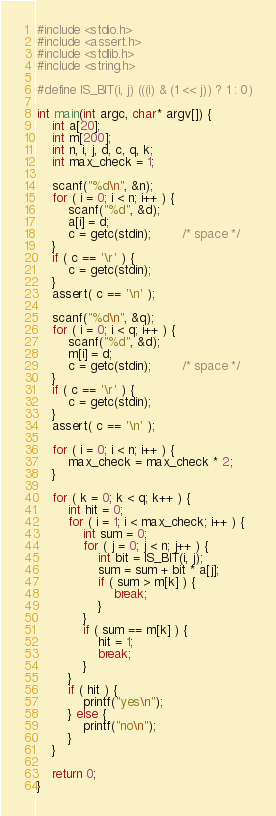<code> <loc_0><loc_0><loc_500><loc_500><_C_>#include <stdio.h>
#include <assert.h>
#include <stdlib.h>
#include <string.h>

#define IS_BIT(i, j) (((i) & (1 << j)) ? 1 : 0)

int main(int argc, char* argv[]) {
    int a[20];
    int m[200];
    int n, i, j, d, c, q, k;
    int max_check = 1;

    scanf("%d\n", &n);
    for ( i = 0; i < n; i++ ) {
        scanf("%d", &d);
        a[i] = d;
        c = getc(stdin);        /* space */
    }
    if ( c == '\r' ) {
        c = getc(stdin);
    }
    assert( c == '\n' );

    scanf("%d\n", &q);
    for ( i = 0; i < q; i++ ) {
        scanf("%d", &d);
        m[i] = d;
        c = getc(stdin);        /* space */
    }
    if ( c == '\r' ) {
        c = getc(stdin);
    }
    assert( c == '\n' );

    for ( i = 0; i < n; i++ ) {
        max_check = max_check * 2;
    }

    for ( k = 0; k < q; k++ ) {
        int hit = 0;
        for ( i = 1; i < max_check; i++ ) {
            int sum = 0;
            for ( j = 0; j < n; j++ ) {
                int bit = IS_BIT(i, j);
                sum = sum + bit * a[j];
                if ( sum > m[k] ) {
                    break;
                }
            }
            if ( sum == m[k] ) {
                hit = 1;
                break;
            }
        }
        if ( hit ) {
            printf("yes\n");
        } else {
            printf("no\n");
        }
    }

    return 0;
}

</code> 